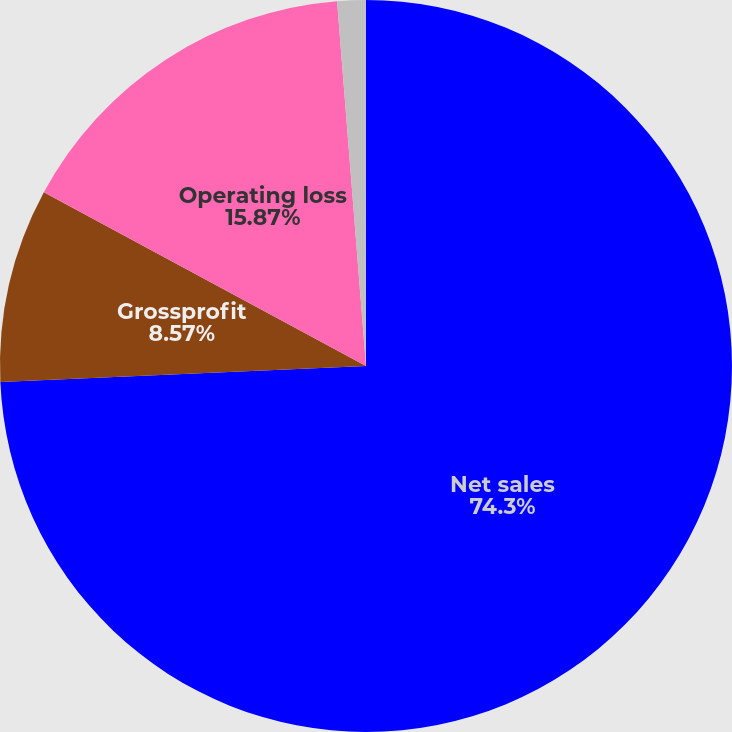Convert chart to OTSL. <chart><loc_0><loc_0><loc_500><loc_500><pie_chart><fcel>Net sales<fcel>Grossprofit<fcel>Operating loss<fcel>Netloss<nl><fcel>74.3%<fcel>8.57%<fcel>15.87%<fcel>1.26%<nl></chart> 